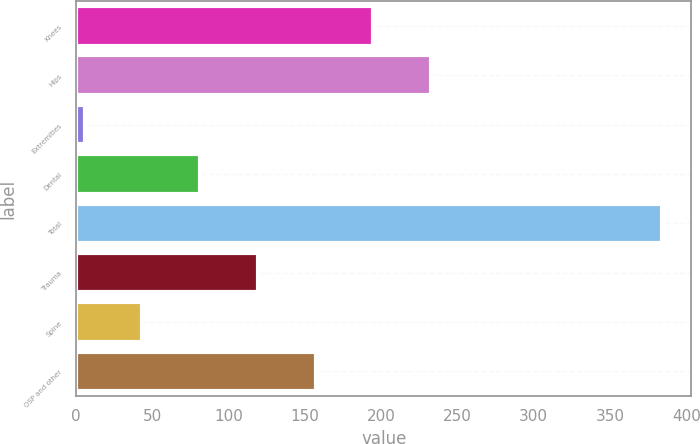Convert chart. <chart><loc_0><loc_0><loc_500><loc_500><bar_chart><fcel>Knees<fcel>Hips<fcel>Extremities<fcel>Dental<fcel>Total<fcel>Trauma<fcel>Spine<fcel>OSP and other<nl><fcel>194.85<fcel>232.72<fcel>5.5<fcel>81.24<fcel>384.2<fcel>119.11<fcel>43.37<fcel>156.98<nl></chart> 